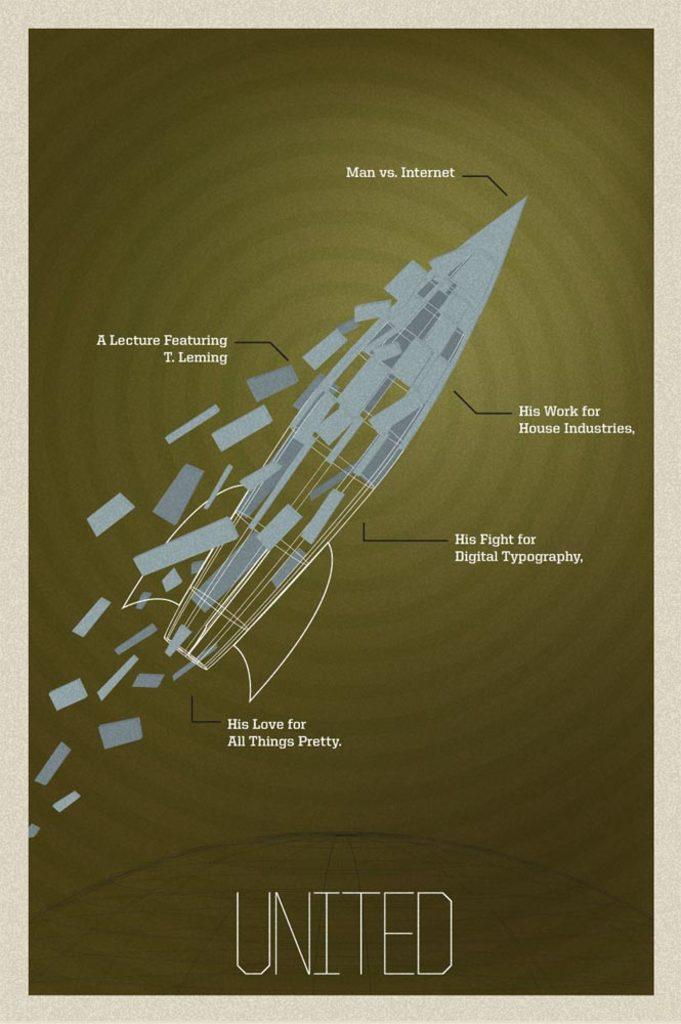Man vs. what?
Provide a succinct answer. Internet. 